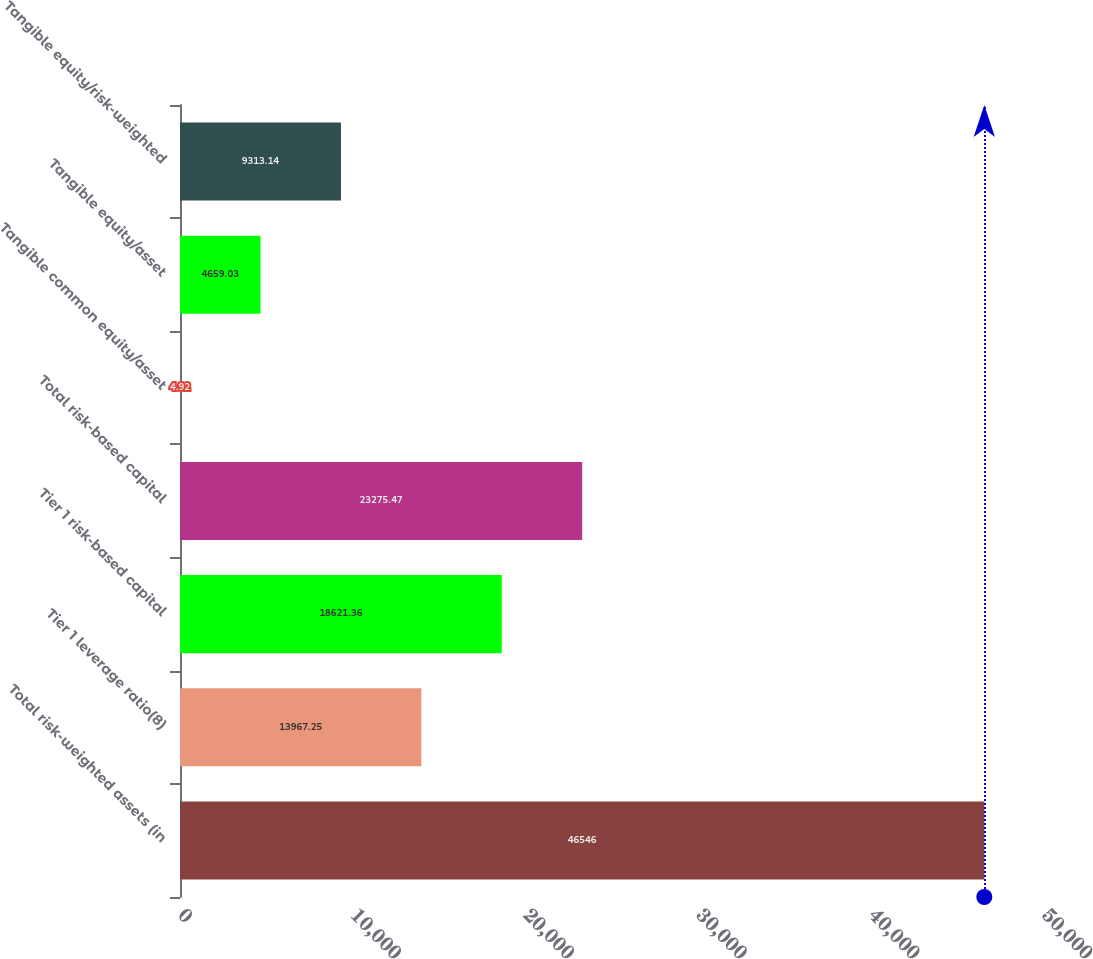Convert chart to OTSL. <chart><loc_0><loc_0><loc_500><loc_500><bar_chart><fcel>Total risk-weighted assets (in<fcel>Tier 1 leverage ratio(8)<fcel>Tier 1 risk-based capital<fcel>Total risk-based capital<fcel>Tangible common equity/asset<fcel>Tangible equity/asset<fcel>Tangible equity/risk-weighted<nl><fcel>46546<fcel>13967.2<fcel>18621.4<fcel>23275.5<fcel>4.92<fcel>4659.03<fcel>9313.14<nl></chart> 